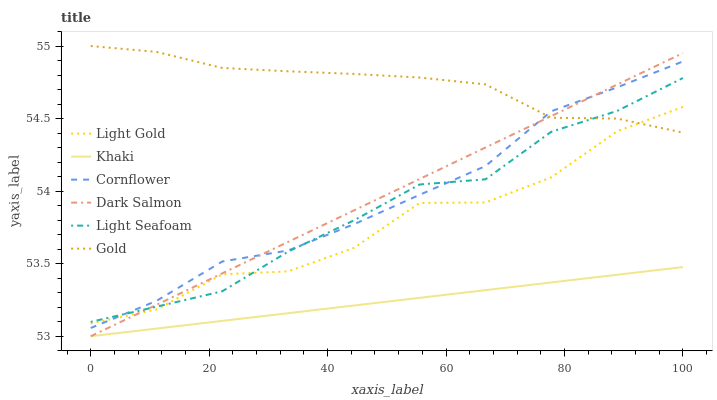Does Khaki have the minimum area under the curve?
Answer yes or no. Yes. Does Gold have the maximum area under the curve?
Answer yes or no. Yes. Does Gold have the minimum area under the curve?
Answer yes or no. No. Does Khaki have the maximum area under the curve?
Answer yes or no. No. Is Dark Salmon the smoothest?
Answer yes or no. Yes. Is Light Gold the roughest?
Answer yes or no. Yes. Is Khaki the smoothest?
Answer yes or no. No. Is Khaki the roughest?
Answer yes or no. No. Does Khaki have the lowest value?
Answer yes or no. Yes. Does Gold have the lowest value?
Answer yes or no. No. Does Gold have the highest value?
Answer yes or no. Yes. Does Khaki have the highest value?
Answer yes or no. No. Is Khaki less than Cornflower?
Answer yes or no. Yes. Is Gold greater than Khaki?
Answer yes or no. Yes. Does Cornflower intersect Light Gold?
Answer yes or no. Yes. Is Cornflower less than Light Gold?
Answer yes or no. No. Is Cornflower greater than Light Gold?
Answer yes or no. No. Does Khaki intersect Cornflower?
Answer yes or no. No. 